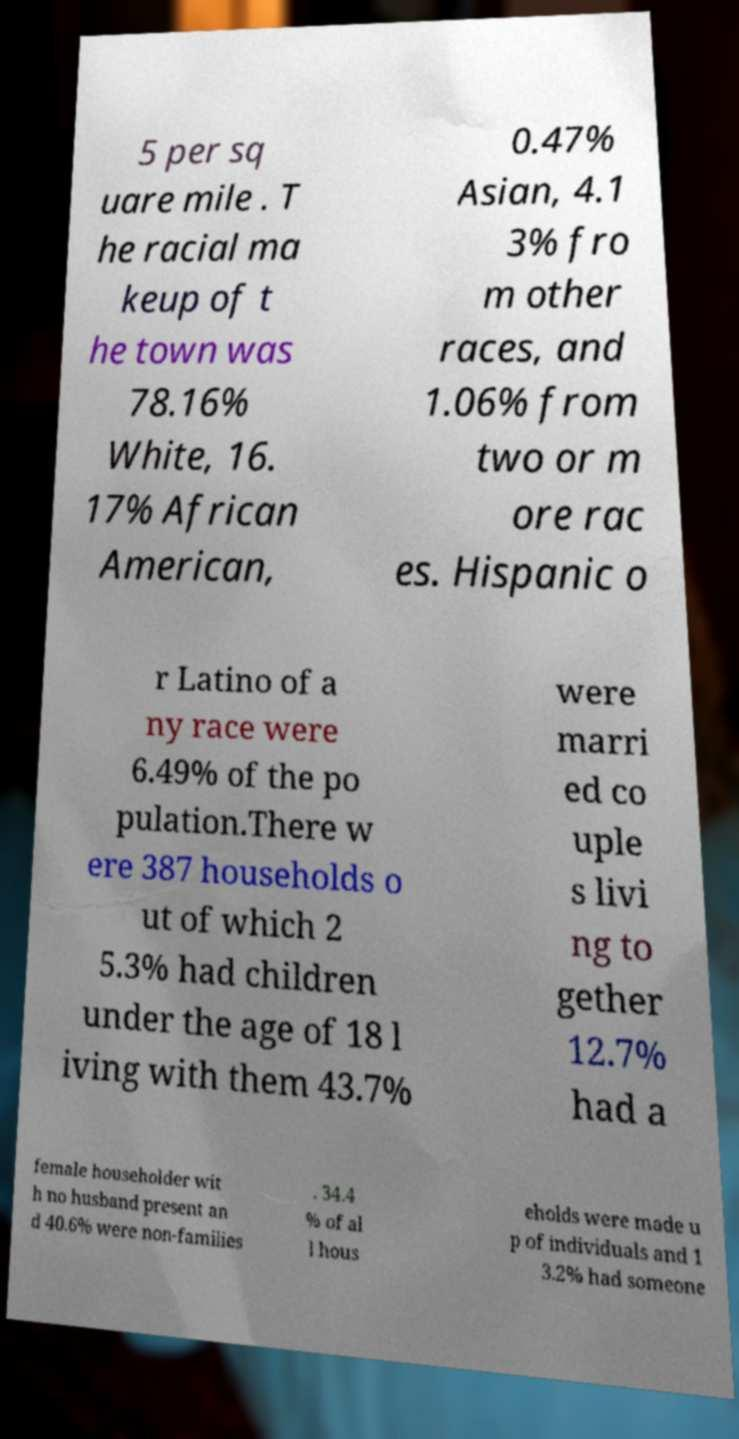For documentation purposes, I need the text within this image transcribed. Could you provide that? 5 per sq uare mile . T he racial ma keup of t he town was 78.16% White, 16. 17% African American, 0.47% Asian, 4.1 3% fro m other races, and 1.06% from two or m ore rac es. Hispanic o r Latino of a ny race were 6.49% of the po pulation.There w ere 387 households o ut of which 2 5.3% had children under the age of 18 l iving with them 43.7% were marri ed co uple s livi ng to gether 12.7% had a female householder wit h no husband present an d 40.6% were non-families . 34.4 % of al l hous eholds were made u p of individuals and 1 3.2% had someone 